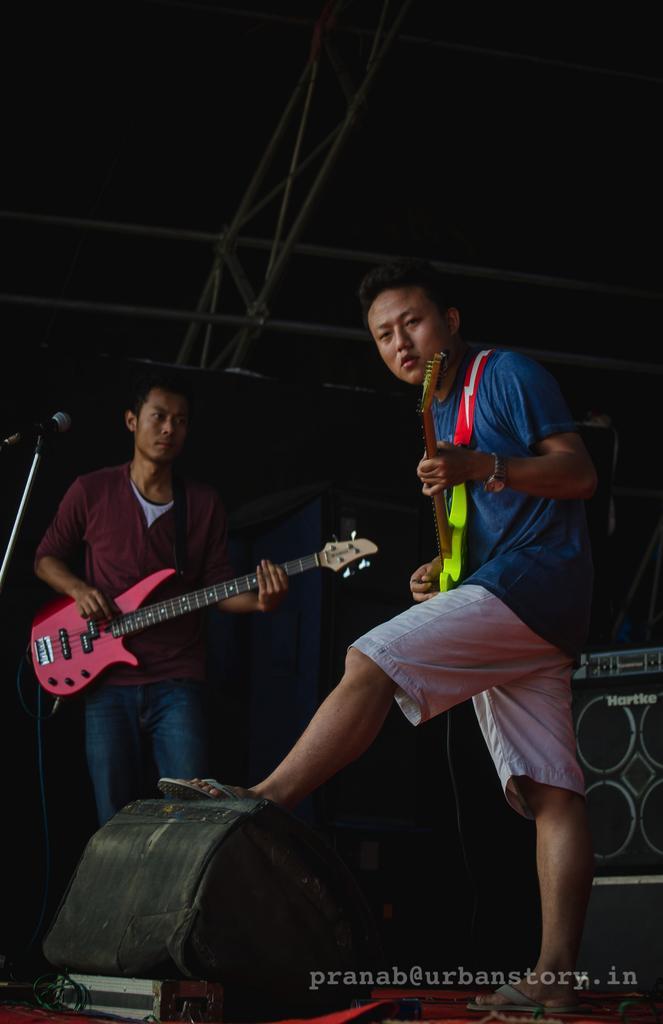Please provide a concise description of this image. In this image, we can see persons wearing clothes and playing guitars. There is a light at the bottom of the image. There is a mic on the left side of the image. There is a speaker on the right side of the image. There is a metal frame at the top of the image. 